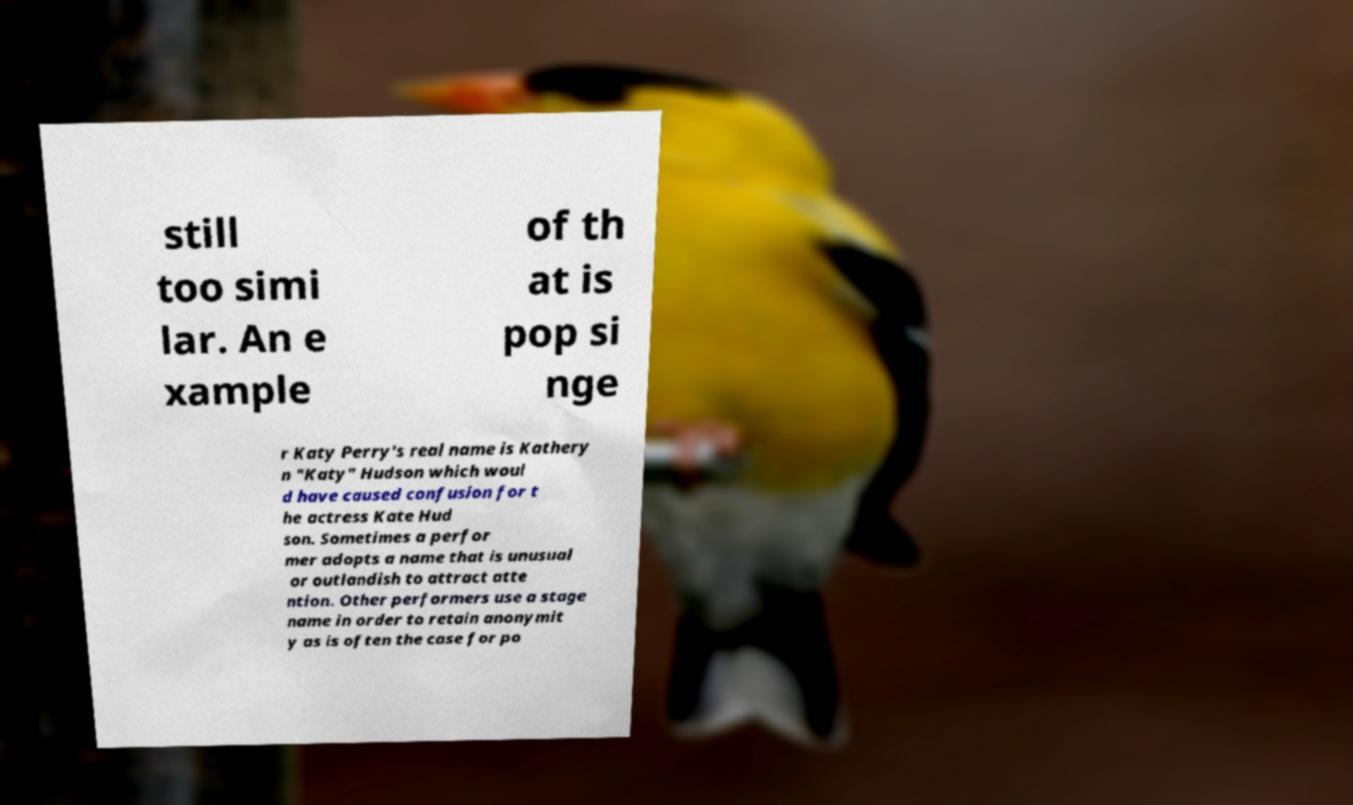Could you assist in decoding the text presented in this image and type it out clearly? still too simi lar. An e xample of th at is pop si nge r Katy Perry's real name is Kathery n "Katy" Hudson which woul d have caused confusion for t he actress Kate Hud son. Sometimes a perfor mer adopts a name that is unusual or outlandish to attract atte ntion. Other performers use a stage name in order to retain anonymit y as is often the case for po 